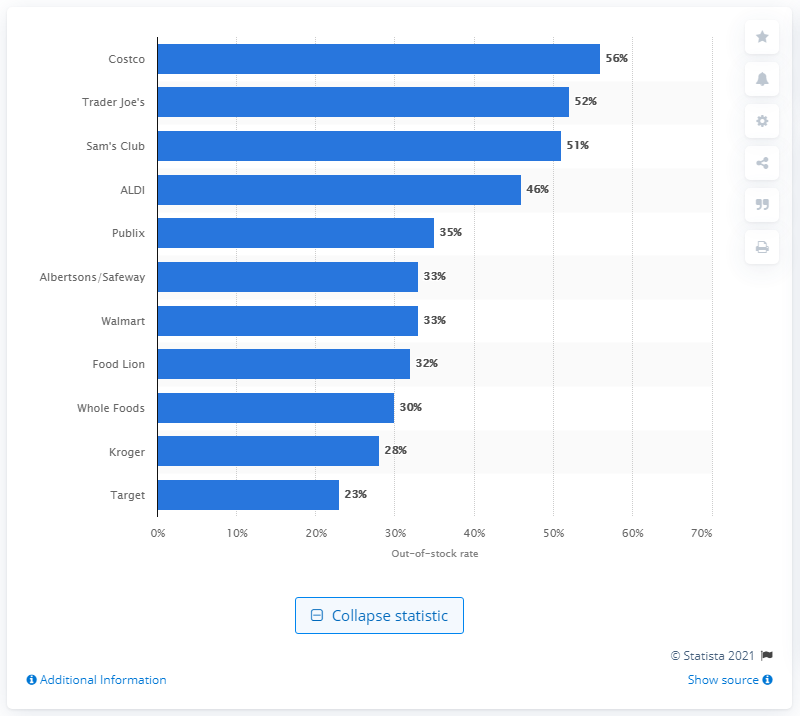Indicate a few pertinent items in this graphic. Based on the information available as of March 19, 2020, Walmart's out-of-stock rate was 33%. 